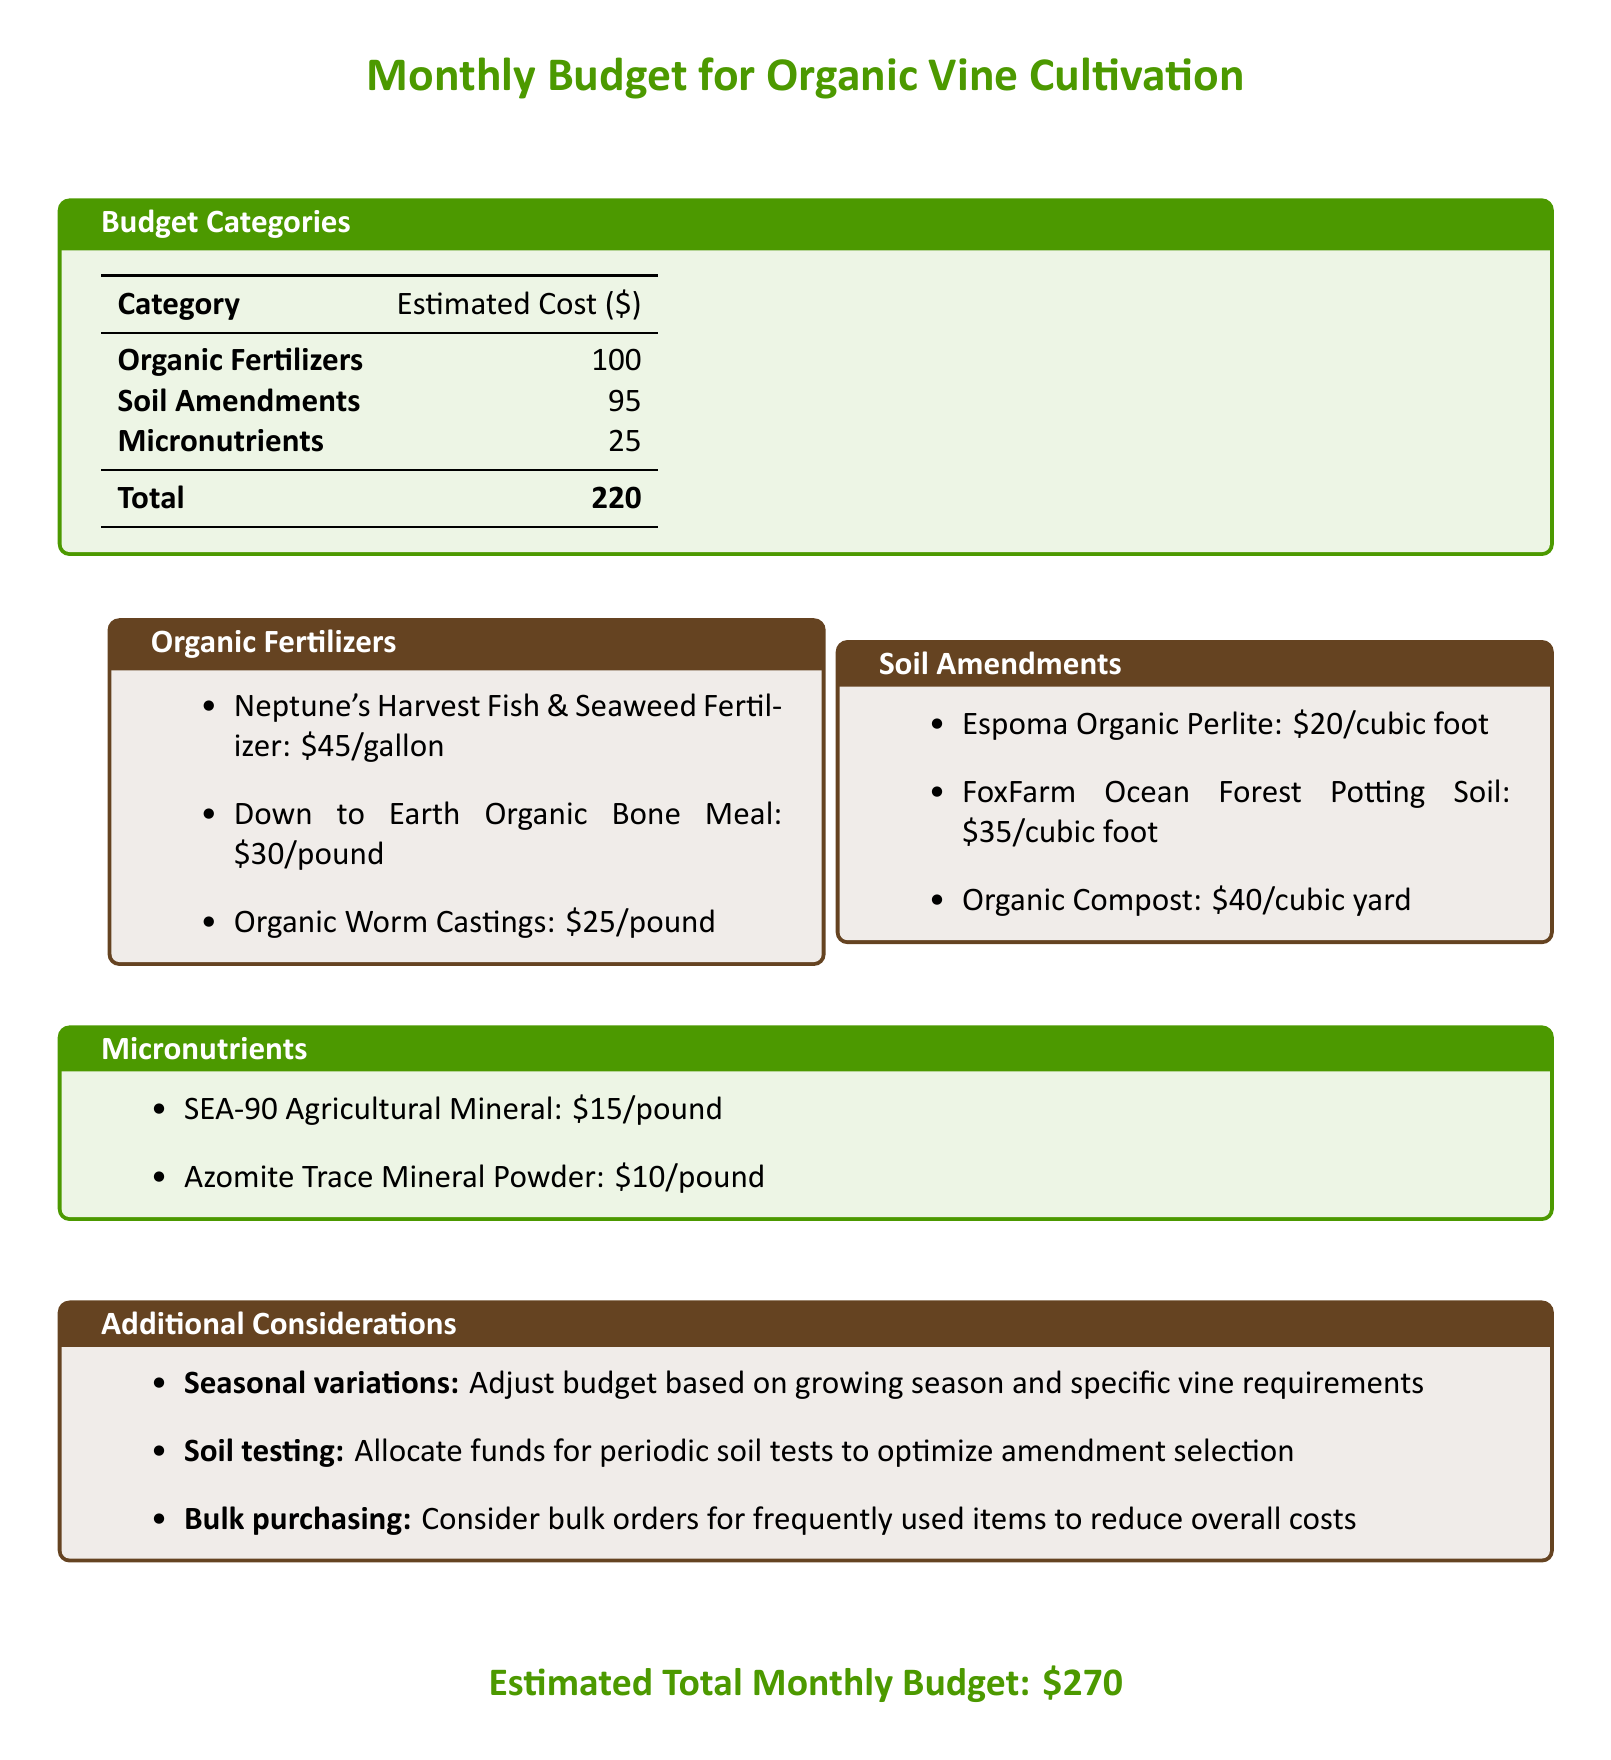What is the total estimated cost for organic fertilizers? The total estimated cost for organic fertilizers is listed as $100 in the budget table.
Answer: $100 How much does a gallon of Neptune's Harvest cost? The document specifies that Neptune's Harvest Fish & Seaweed Fertilizer costs $45 per gallon.
Answer: $45 What is the cost of organic compost per cubic yard? According to the document, organic compost costs $40 per cubic yard under the soil amendments section.
Answer: $40 How much is allocated for micronutrients? The budget document states that the cost allocated for micronutrients is $25.
Answer: $25 What is the total estimated monthly budget? The document summarizes the total estimated monthly budget as $270 at the bottom.
Answer: $270 What should be considered for bulk purchasing? The document mentions considering bulk orders for frequently used items to reduce overall costs under additional considerations.
Answer: Bulk orders How much does Azomite Trace Mineral Powder cost? The document lists Azomite Trace Mineral Powder at $10 per pound in the micronutrients section.
Answer: $10 What is the cost of Down to Earth Organic Bone Meal? The document states that Down to Earth Organic Bone Meal costs $30 per pound in the organic fertilizers section.
Answer: $30 What should be adjusted based on the growing season? According to the document, the budget should be adjusted based on growing season and specific vine requirements under additional considerations.
Answer: Budget adjustment 